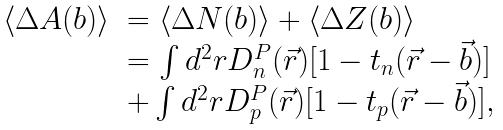<formula> <loc_0><loc_0><loc_500><loc_500>\begin{array} { l l } \langle \Delta A ( b ) \rangle & = \langle \Delta N ( b ) \rangle + \langle \Delta Z ( b ) \rangle \\ & = \int d ^ { 2 } r D _ { n } ^ { P } ( \vec { r } ) [ 1 - t _ { n } ( \vec { r } - \vec { b } ) ] \\ & + \int d ^ { 2 } r D _ { p } ^ { P } ( \vec { r } ) [ 1 - t _ { p } ( \vec { r } - \vec { b } ) ] , \end{array}</formula> 